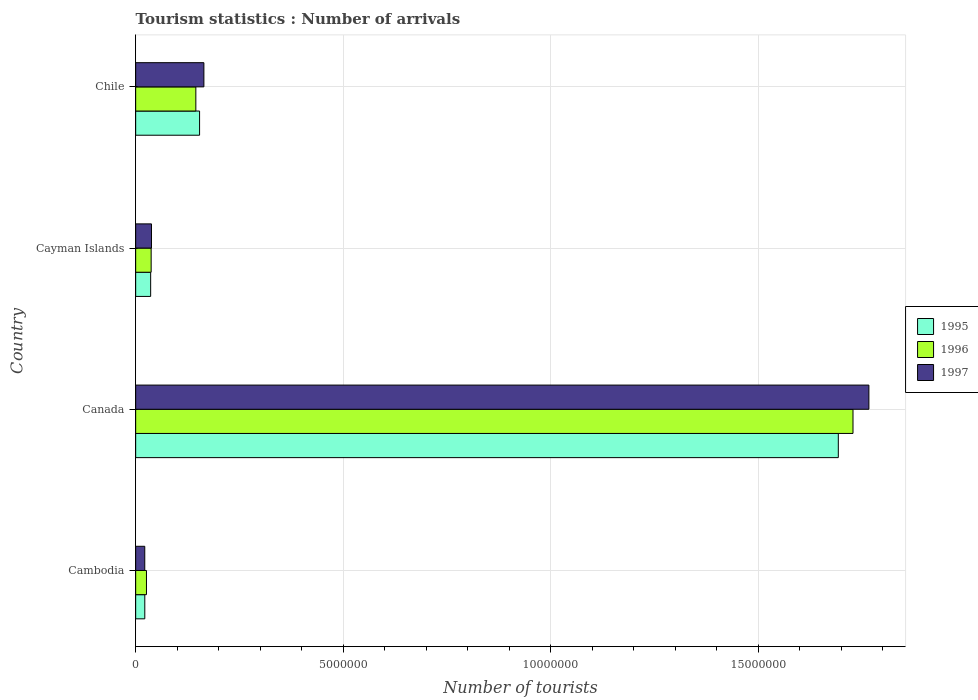How many different coloured bars are there?
Make the answer very short. 3. How many groups of bars are there?
Provide a short and direct response. 4. Are the number of bars on each tick of the Y-axis equal?
Provide a succinct answer. Yes. How many bars are there on the 3rd tick from the top?
Your response must be concise. 3. How many bars are there on the 3rd tick from the bottom?
Your answer should be very brief. 3. What is the number of tourist arrivals in 1997 in Canada?
Your answer should be compact. 1.77e+07. Across all countries, what is the maximum number of tourist arrivals in 1997?
Your answer should be compact. 1.77e+07. Across all countries, what is the minimum number of tourist arrivals in 1995?
Keep it short and to the point. 2.20e+05. In which country was the number of tourist arrivals in 1996 minimum?
Ensure brevity in your answer.  Cambodia. What is the total number of tourist arrivals in 1996 in the graph?
Keep it short and to the point. 1.94e+07. What is the difference between the number of tourist arrivals in 1995 in Cayman Islands and that in Chile?
Your response must be concise. -1.18e+06. What is the difference between the number of tourist arrivals in 1996 in Canada and the number of tourist arrivals in 1995 in Chile?
Keep it short and to the point. 1.57e+07. What is the average number of tourist arrivals in 1996 per country?
Give a very brief answer. 4.84e+06. What is the difference between the number of tourist arrivals in 1995 and number of tourist arrivals in 1997 in Chile?
Offer a very short reply. -1.04e+05. What is the ratio of the number of tourist arrivals in 1997 in Cayman Islands to that in Chile?
Make the answer very short. 0.23. What is the difference between the highest and the second highest number of tourist arrivals in 1995?
Make the answer very short. 1.54e+07. What is the difference between the highest and the lowest number of tourist arrivals in 1995?
Provide a succinct answer. 1.67e+07. What does the 2nd bar from the top in Chile represents?
Your answer should be compact. 1996. Is it the case that in every country, the sum of the number of tourist arrivals in 1997 and number of tourist arrivals in 1995 is greater than the number of tourist arrivals in 1996?
Make the answer very short. Yes. What is the difference between two consecutive major ticks on the X-axis?
Your answer should be compact. 5.00e+06. Does the graph contain any zero values?
Offer a terse response. No. Does the graph contain grids?
Give a very brief answer. Yes. How many legend labels are there?
Keep it short and to the point. 3. What is the title of the graph?
Offer a very short reply. Tourism statistics : Number of arrivals. Does "1994" appear as one of the legend labels in the graph?
Your answer should be compact. No. What is the label or title of the X-axis?
Your answer should be very brief. Number of tourists. What is the Number of tourists in 1996 in Cambodia?
Keep it short and to the point. 2.60e+05. What is the Number of tourists in 1997 in Cambodia?
Offer a very short reply. 2.19e+05. What is the Number of tourists in 1995 in Canada?
Provide a succinct answer. 1.69e+07. What is the Number of tourists of 1996 in Canada?
Ensure brevity in your answer.  1.73e+07. What is the Number of tourists of 1997 in Canada?
Your response must be concise. 1.77e+07. What is the Number of tourists in 1995 in Cayman Islands?
Keep it short and to the point. 3.61e+05. What is the Number of tourists of 1996 in Cayman Islands?
Your answer should be very brief. 3.73e+05. What is the Number of tourists in 1997 in Cayman Islands?
Provide a short and direct response. 3.81e+05. What is the Number of tourists in 1995 in Chile?
Offer a very short reply. 1.54e+06. What is the Number of tourists in 1996 in Chile?
Keep it short and to the point. 1.45e+06. What is the Number of tourists of 1997 in Chile?
Make the answer very short. 1.64e+06. Across all countries, what is the maximum Number of tourists of 1995?
Provide a succinct answer. 1.69e+07. Across all countries, what is the maximum Number of tourists in 1996?
Provide a short and direct response. 1.73e+07. Across all countries, what is the maximum Number of tourists of 1997?
Your response must be concise. 1.77e+07. Across all countries, what is the minimum Number of tourists of 1997?
Your answer should be compact. 2.19e+05. What is the total Number of tourists of 1995 in the graph?
Give a very brief answer. 1.91e+07. What is the total Number of tourists of 1996 in the graph?
Provide a succinct answer. 1.94e+07. What is the total Number of tourists in 1997 in the graph?
Provide a succinct answer. 1.99e+07. What is the difference between the Number of tourists of 1995 in Cambodia and that in Canada?
Your response must be concise. -1.67e+07. What is the difference between the Number of tourists of 1996 in Cambodia and that in Canada?
Provide a succinct answer. -1.70e+07. What is the difference between the Number of tourists of 1997 in Cambodia and that in Canada?
Your response must be concise. -1.74e+07. What is the difference between the Number of tourists of 1995 in Cambodia and that in Cayman Islands?
Keep it short and to the point. -1.41e+05. What is the difference between the Number of tourists in 1996 in Cambodia and that in Cayman Islands?
Keep it short and to the point. -1.13e+05. What is the difference between the Number of tourists of 1997 in Cambodia and that in Cayman Islands?
Offer a terse response. -1.62e+05. What is the difference between the Number of tourists of 1995 in Cambodia and that in Chile?
Offer a very short reply. -1.32e+06. What is the difference between the Number of tourists of 1996 in Cambodia and that in Chile?
Keep it short and to the point. -1.19e+06. What is the difference between the Number of tourists in 1997 in Cambodia and that in Chile?
Ensure brevity in your answer.  -1.42e+06. What is the difference between the Number of tourists of 1995 in Canada and that in Cayman Islands?
Offer a terse response. 1.66e+07. What is the difference between the Number of tourists in 1996 in Canada and that in Cayman Islands?
Your answer should be compact. 1.69e+07. What is the difference between the Number of tourists in 1997 in Canada and that in Cayman Islands?
Your response must be concise. 1.73e+07. What is the difference between the Number of tourists of 1995 in Canada and that in Chile?
Your response must be concise. 1.54e+07. What is the difference between the Number of tourists in 1996 in Canada and that in Chile?
Offer a terse response. 1.58e+07. What is the difference between the Number of tourists in 1997 in Canada and that in Chile?
Provide a succinct answer. 1.60e+07. What is the difference between the Number of tourists of 1995 in Cayman Islands and that in Chile?
Your answer should be compact. -1.18e+06. What is the difference between the Number of tourists in 1996 in Cayman Islands and that in Chile?
Give a very brief answer. -1.08e+06. What is the difference between the Number of tourists in 1997 in Cayman Islands and that in Chile?
Your answer should be very brief. -1.26e+06. What is the difference between the Number of tourists of 1995 in Cambodia and the Number of tourists of 1996 in Canada?
Ensure brevity in your answer.  -1.71e+07. What is the difference between the Number of tourists of 1995 in Cambodia and the Number of tourists of 1997 in Canada?
Provide a short and direct response. -1.74e+07. What is the difference between the Number of tourists in 1996 in Cambodia and the Number of tourists in 1997 in Canada?
Offer a very short reply. -1.74e+07. What is the difference between the Number of tourists of 1995 in Cambodia and the Number of tourists of 1996 in Cayman Islands?
Make the answer very short. -1.53e+05. What is the difference between the Number of tourists in 1995 in Cambodia and the Number of tourists in 1997 in Cayman Islands?
Provide a short and direct response. -1.61e+05. What is the difference between the Number of tourists of 1996 in Cambodia and the Number of tourists of 1997 in Cayman Islands?
Provide a succinct answer. -1.21e+05. What is the difference between the Number of tourists in 1995 in Cambodia and the Number of tourists in 1996 in Chile?
Your answer should be compact. -1.23e+06. What is the difference between the Number of tourists in 1995 in Cambodia and the Number of tourists in 1997 in Chile?
Offer a terse response. -1.42e+06. What is the difference between the Number of tourists in 1996 in Cambodia and the Number of tourists in 1997 in Chile?
Your answer should be compact. -1.38e+06. What is the difference between the Number of tourists in 1995 in Canada and the Number of tourists in 1996 in Cayman Islands?
Offer a very short reply. 1.66e+07. What is the difference between the Number of tourists in 1995 in Canada and the Number of tourists in 1997 in Cayman Islands?
Provide a short and direct response. 1.66e+07. What is the difference between the Number of tourists of 1996 in Canada and the Number of tourists of 1997 in Cayman Islands?
Make the answer very short. 1.69e+07. What is the difference between the Number of tourists in 1995 in Canada and the Number of tourists in 1996 in Chile?
Offer a terse response. 1.55e+07. What is the difference between the Number of tourists of 1995 in Canada and the Number of tourists of 1997 in Chile?
Offer a terse response. 1.53e+07. What is the difference between the Number of tourists of 1996 in Canada and the Number of tourists of 1997 in Chile?
Make the answer very short. 1.56e+07. What is the difference between the Number of tourists in 1995 in Cayman Islands and the Number of tourists in 1996 in Chile?
Make the answer very short. -1.09e+06. What is the difference between the Number of tourists of 1995 in Cayman Islands and the Number of tourists of 1997 in Chile?
Your answer should be compact. -1.28e+06. What is the difference between the Number of tourists of 1996 in Cayman Islands and the Number of tourists of 1997 in Chile?
Your response must be concise. -1.27e+06. What is the average Number of tourists in 1995 per country?
Offer a terse response. 4.76e+06. What is the average Number of tourists in 1996 per country?
Provide a short and direct response. 4.84e+06. What is the average Number of tourists in 1997 per country?
Provide a succinct answer. 4.98e+06. What is the difference between the Number of tourists of 1995 and Number of tourists of 1996 in Cambodia?
Your response must be concise. -4.00e+04. What is the difference between the Number of tourists of 1996 and Number of tourists of 1997 in Cambodia?
Provide a short and direct response. 4.10e+04. What is the difference between the Number of tourists in 1995 and Number of tourists in 1996 in Canada?
Make the answer very short. -3.54e+05. What is the difference between the Number of tourists in 1995 and Number of tourists in 1997 in Canada?
Offer a terse response. -7.37e+05. What is the difference between the Number of tourists in 1996 and Number of tourists in 1997 in Canada?
Offer a very short reply. -3.83e+05. What is the difference between the Number of tourists of 1995 and Number of tourists of 1996 in Cayman Islands?
Your response must be concise. -1.20e+04. What is the difference between the Number of tourists of 1995 and Number of tourists of 1997 in Cayman Islands?
Keep it short and to the point. -2.00e+04. What is the difference between the Number of tourists of 1996 and Number of tourists of 1997 in Cayman Islands?
Your answer should be very brief. -8000. What is the difference between the Number of tourists of 1995 and Number of tourists of 1996 in Chile?
Your answer should be very brief. 9.00e+04. What is the difference between the Number of tourists of 1995 and Number of tourists of 1997 in Chile?
Make the answer very short. -1.04e+05. What is the difference between the Number of tourists in 1996 and Number of tourists in 1997 in Chile?
Make the answer very short. -1.94e+05. What is the ratio of the Number of tourists in 1995 in Cambodia to that in Canada?
Offer a terse response. 0.01. What is the ratio of the Number of tourists of 1996 in Cambodia to that in Canada?
Give a very brief answer. 0.01. What is the ratio of the Number of tourists of 1997 in Cambodia to that in Canada?
Offer a very short reply. 0.01. What is the ratio of the Number of tourists of 1995 in Cambodia to that in Cayman Islands?
Offer a very short reply. 0.61. What is the ratio of the Number of tourists in 1996 in Cambodia to that in Cayman Islands?
Give a very brief answer. 0.7. What is the ratio of the Number of tourists in 1997 in Cambodia to that in Cayman Islands?
Give a very brief answer. 0.57. What is the ratio of the Number of tourists in 1995 in Cambodia to that in Chile?
Offer a terse response. 0.14. What is the ratio of the Number of tourists of 1996 in Cambodia to that in Chile?
Keep it short and to the point. 0.18. What is the ratio of the Number of tourists in 1997 in Cambodia to that in Chile?
Give a very brief answer. 0.13. What is the ratio of the Number of tourists in 1995 in Canada to that in Cayman Islands?
Offer a very short reply. 46.9. What is the ratio of the Number of tourists of 1996 in Canada to that in Cayman Islands?
Offer a very short reply. 46.34. What is the ratio of the Number of tourists in 1997 in Canada to that in Cayman Islands?
Your response must be concise. 46.38. What is the ratio of the Number of tourists in 1995 in Canada to that in Chile?
Make the answer very short. 10.99. What is the ratio of the Number of tourists in 1996 in Canada to that in Chile?
Your response must be concise. 11.92. What is the ratio of the Number of tourists in 1997 in Canada to that in Chile?
Keep it short and to the point. 10.75. What is the ratio of the Number of tourists of 1995 in Cayman Islands to that in Chile?
Offer a terse response. 0.23. What is the ratio of the Number of tourists of 1996 in Cayman Islands to that in Chile?
Your answer should be very brief. 0.26. What is the ratio of the Number of tourists of 1997 in Cayman Islands to that in Chile?
Offer a terse response. 0.23. What is the difference between the highest and the second highest Number of tourists of 1995?
Offer a very short reply. 1.54e+07. What is the difference between the highest and the second highest Number of tourists in 1996?
Provide a succinct answer. 1.58e+07. What is the difference between the highest and the second highest Number of tourists in 1997?
Provide a short and direct response. 1.60e+07. What is the difference between the highest and the lowest Number of tourists in 1995?
Ensure brevity in your answer.  1.67e+07. What is the difference between the highest and the lowest Number of tourists in 1996?
Your answer should be compact. 1.70e+07. What is the difference between the highest and the lowest Number of tourists of 1997?
Ensure brevity in your answer.  1.74e+07. 